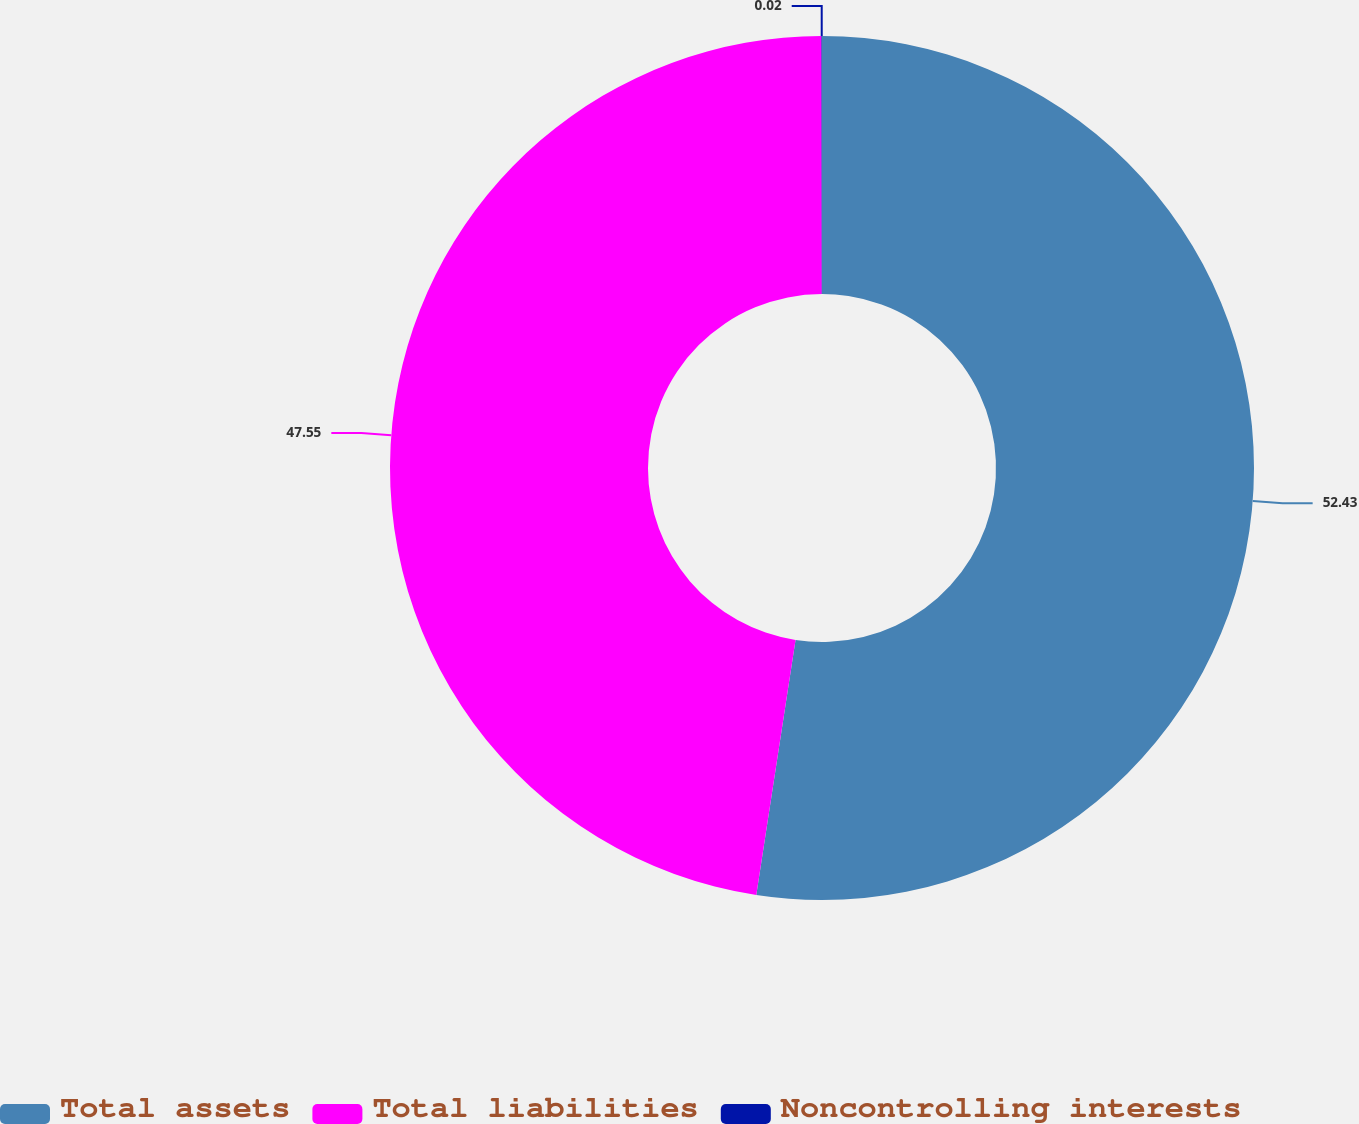<chart> <loc_0><loc_0><loc_500><loc_500><pie_chart><fcel>Total assets<fcel>Total liabilities<fcel>Noncontrolling interests<nl><fcel>52.43%<fcel>47.55%<fcel>0.02%<nl></chart> 